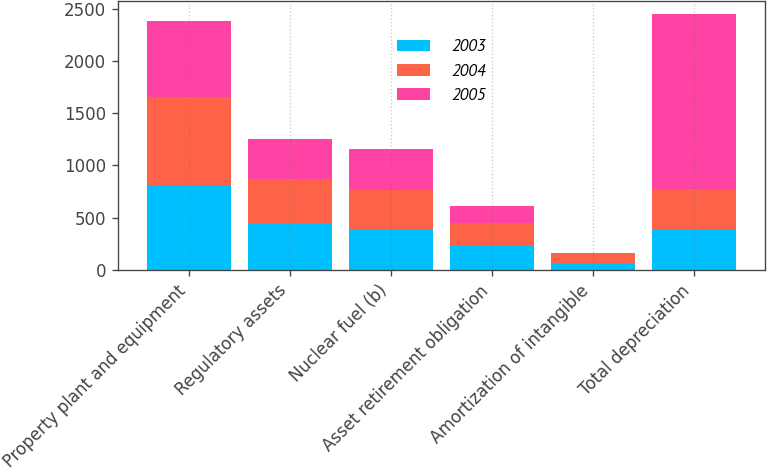<chart> <loc_0><loc_0><loc_500><loc_500><stacked_bar_chart><ecel><fcel>Property plant and equipment<fcel>Regulatory assets<fcel>Nuclear fuel (b)<fcel>Asset retirement obligation<fcel>Amortization of intangible<fcel>Total depreciation<nl><fcel>2003<fcel>816<fcel>454<fcel>385<fcel>243<fcel>69<fcel>385.5<nl><fcel>2004<fcel>835<fcel>418<fcel>380<fcel>210<fcel>90<fcel>385.5<nl><fcel>2005<fcel>736<fcel>386<fcel>395<fcel>160<fcel>4<fcel>1681<nl></chart> 